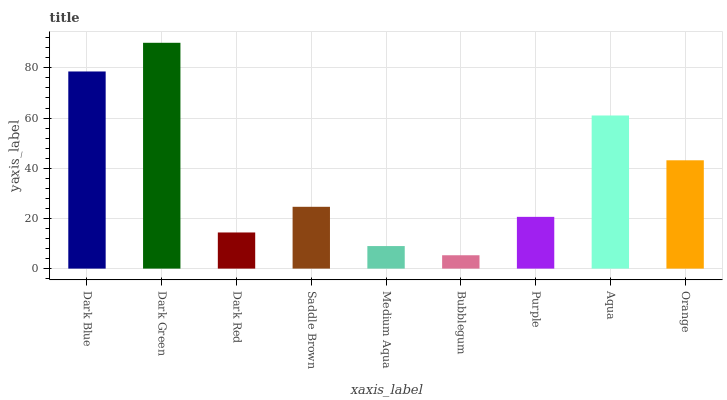Is Dark Red the minimum?
Answer yes or no. No. Is Dark Red the maximum?
Answer yes or no. No. Is Dark Green greater than Dark Red?
Answer yes or no. Yes. Is Dark Red less than Dark Green?
Answer yes or no. Yes. Is Dark Red greater than Dark Green?
Answer yes or no. No. Is Dark Green less than Dark Red?
Answer yes or no. No. Is Saddle Brown the high median?
Answer yes or no. Yes. Is Saddle Brown the low median?
Answer yes or no. Yes. Is Dark Green the high median?
Answer yes or no. No. Is Dark Green the low median?
Answer yes or no. No. 